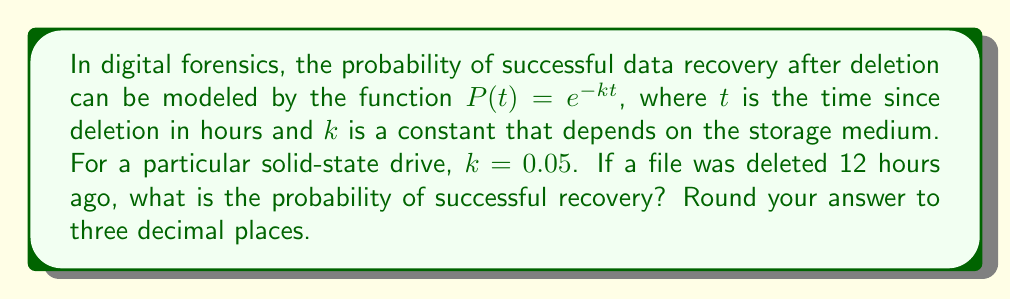Give your solution to this math problem. To solve this problem, we'll follow these steps:

1) We're given the function $P(t) = e^{-kt}$, where:
   $P(t)$ is the probability of successful recovery
   $t$ is the time since deletion in hours
   $k$ is a constant specific to the storage medium

2) We're also given that:
   $k = 0.05$ for this particular solid-state drive
   $t = 12$ hours

3) Let's substitute these values into our function:
   $P(12) = e^{-0.05 * 12}$

4) Simplify the exponent:
   $P(12) = e^{-0.6}$

5) Calculate this value:
   $P(12) = 0.5488116...$ (using a calculator)

6) Rounding to three decimal places:
   $P(12) ≈ 0.549$

Therefore, the probability of successful recovery after 12 hours is approximately 0.549 or 54.9%.
Answer: 0.549 